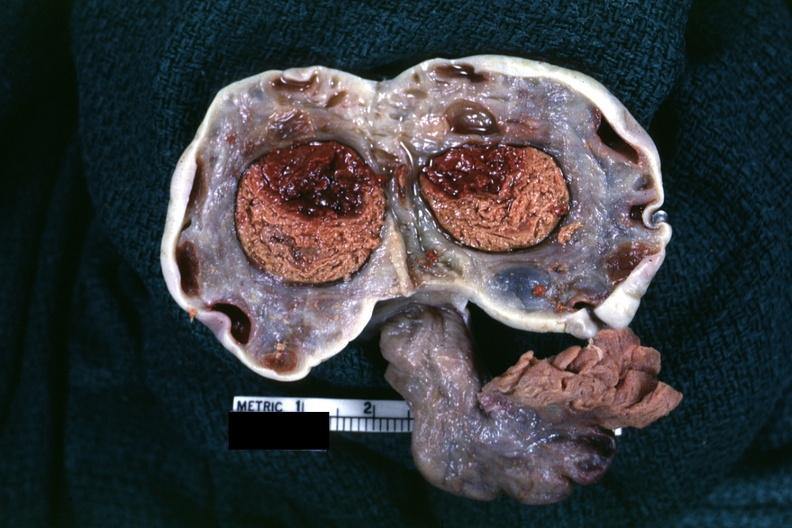what is present?
Answer the question using a single word or phrase. Ovary 